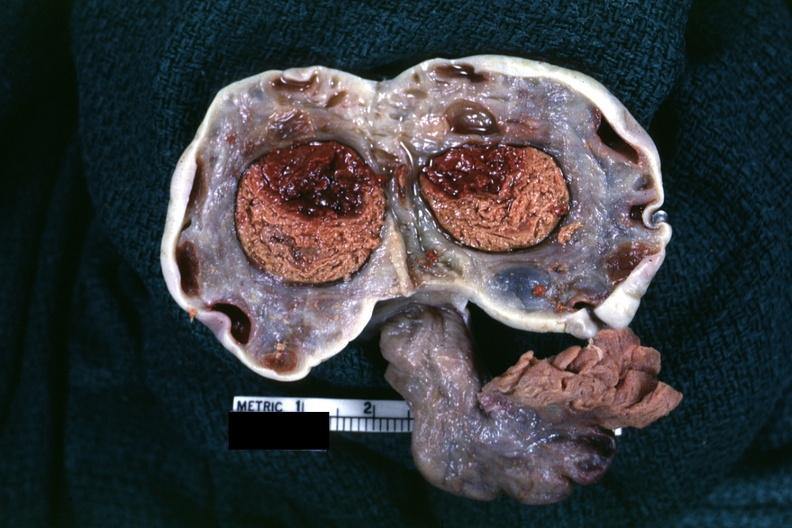what is present?
Answer the question using a single word or phrase. Ovary 